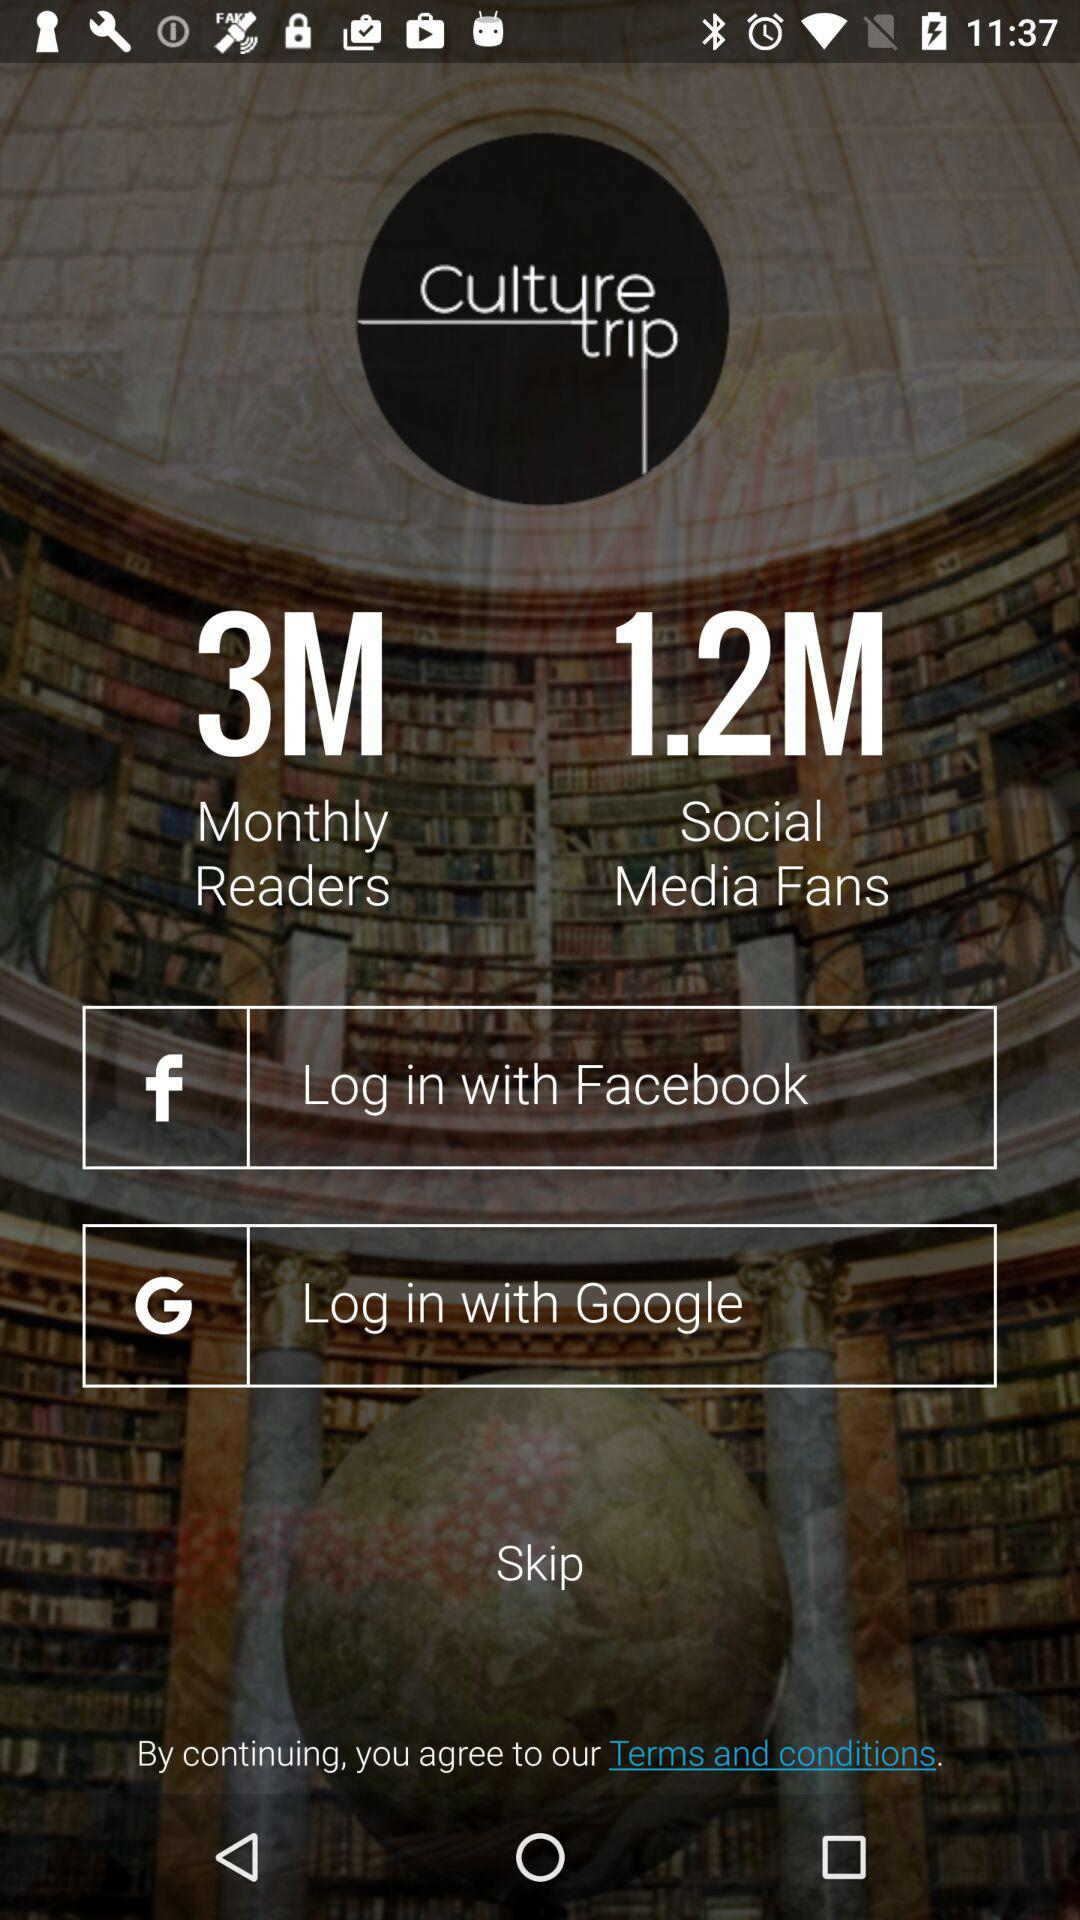What application will receive the public profile, friend list and email address? The application that will receive the public profile, friend list and email address is "Culture Trip". 